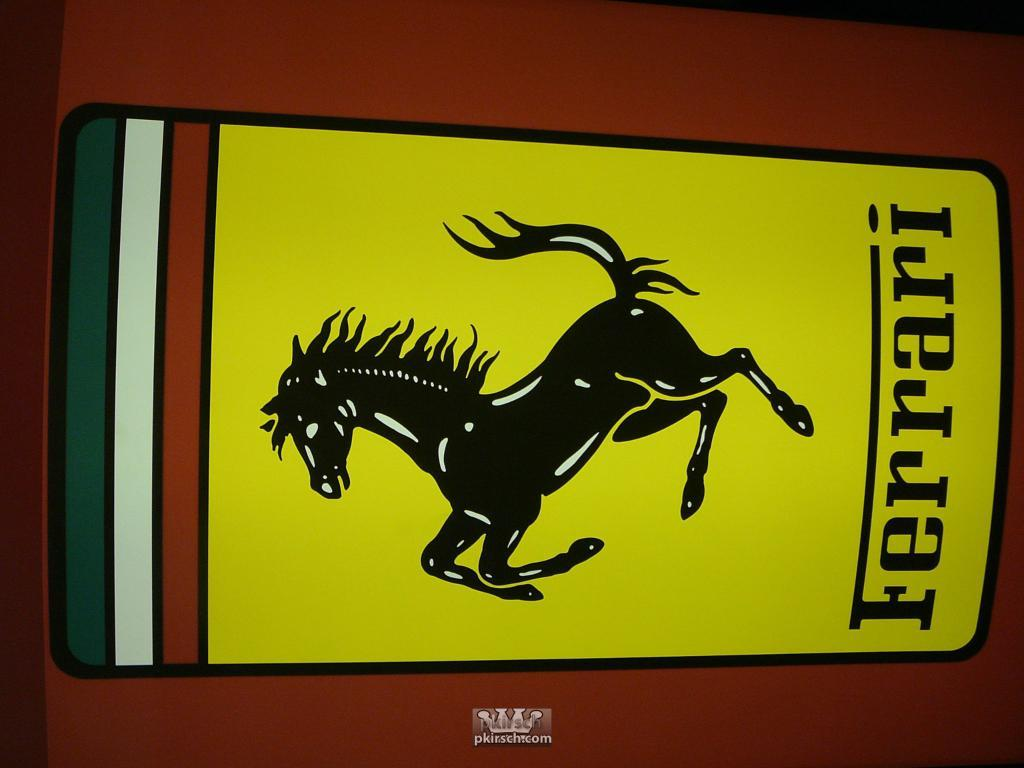What is the main subject in the center of the image? There is an object in the center of the image. What kind of image is on the object? The object has a horse image on it. Are there any words or letters on the object? Yes, there is some text on the object. What type of food is being served at the event depicted in the image? There is no event or food depicted in the image; it only features an object with a horse image and some text. 